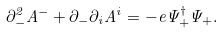<formula> <loc_0><loc_0><loc_500><loc_500>\partial _ { - } ^ { 2 } A ^ { - } + \partial _ { - } \partial _ { i } A ^ { i } = - e \Psi _ { + } ^ { \dagger } \Psi _ { + } .</formula> 